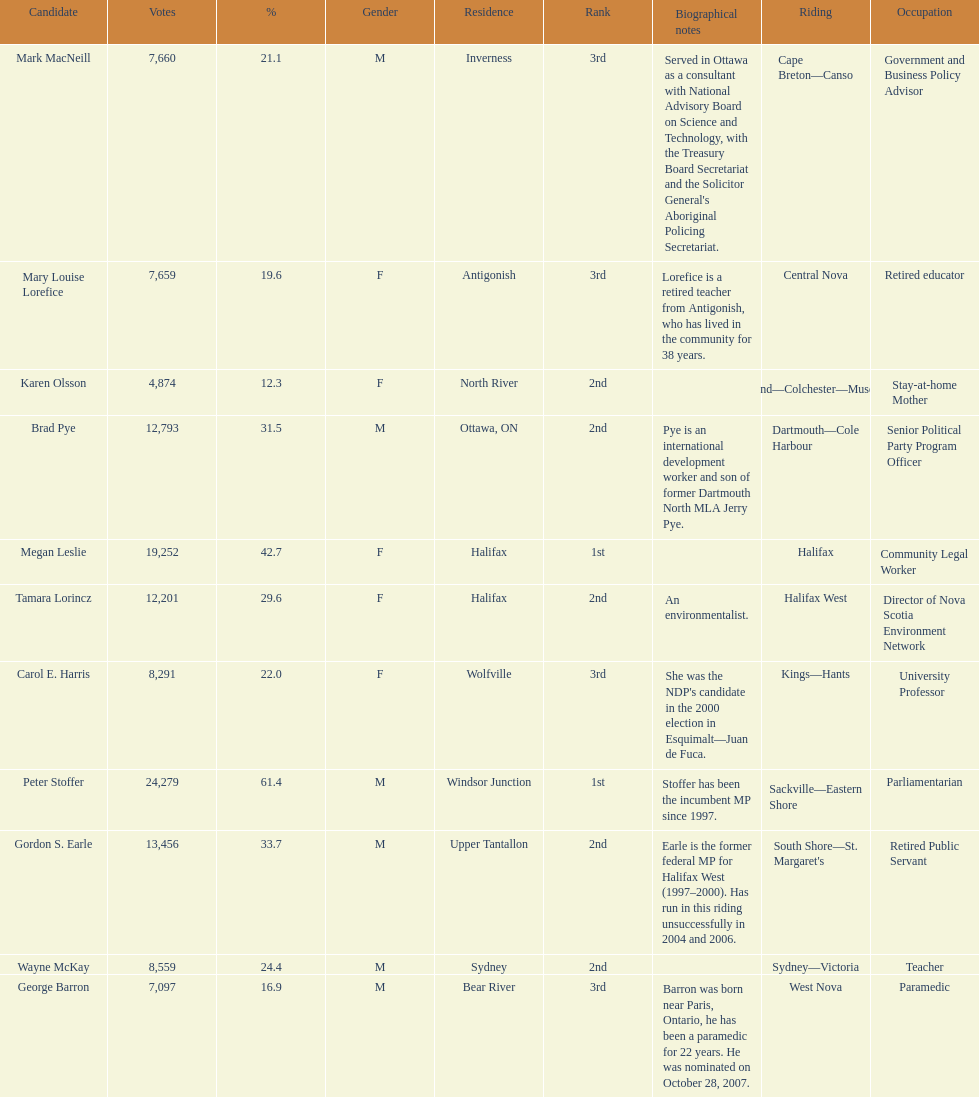What is the total number of candidates? 11. 